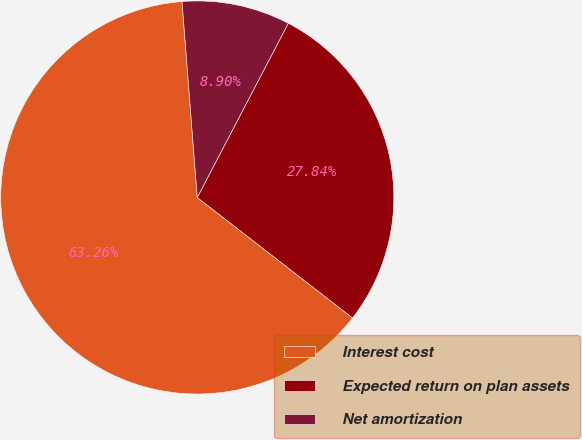Convert chart. <chart><loc_0><loc_0><loc_500><loc_500><pie_chart><fcel>Interest cost<fcel>Expected return on plan assets<fcel>Net amortization<nl><fcel>63.27%<fcel>27.84%<fcel>8.9%<nl></chart> 